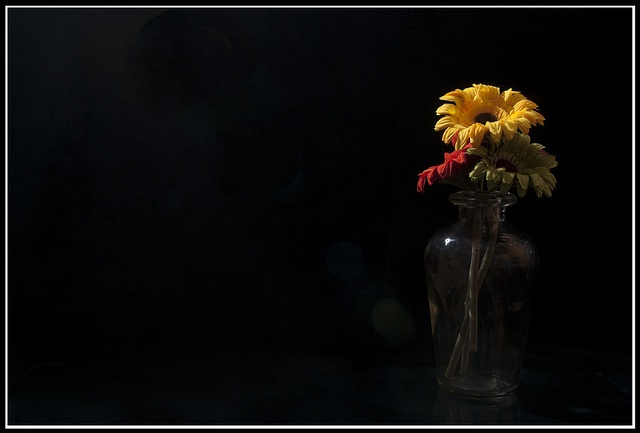Describe the objects in this image and their specific colors. I can see a vase in black and gray tones in this image. 